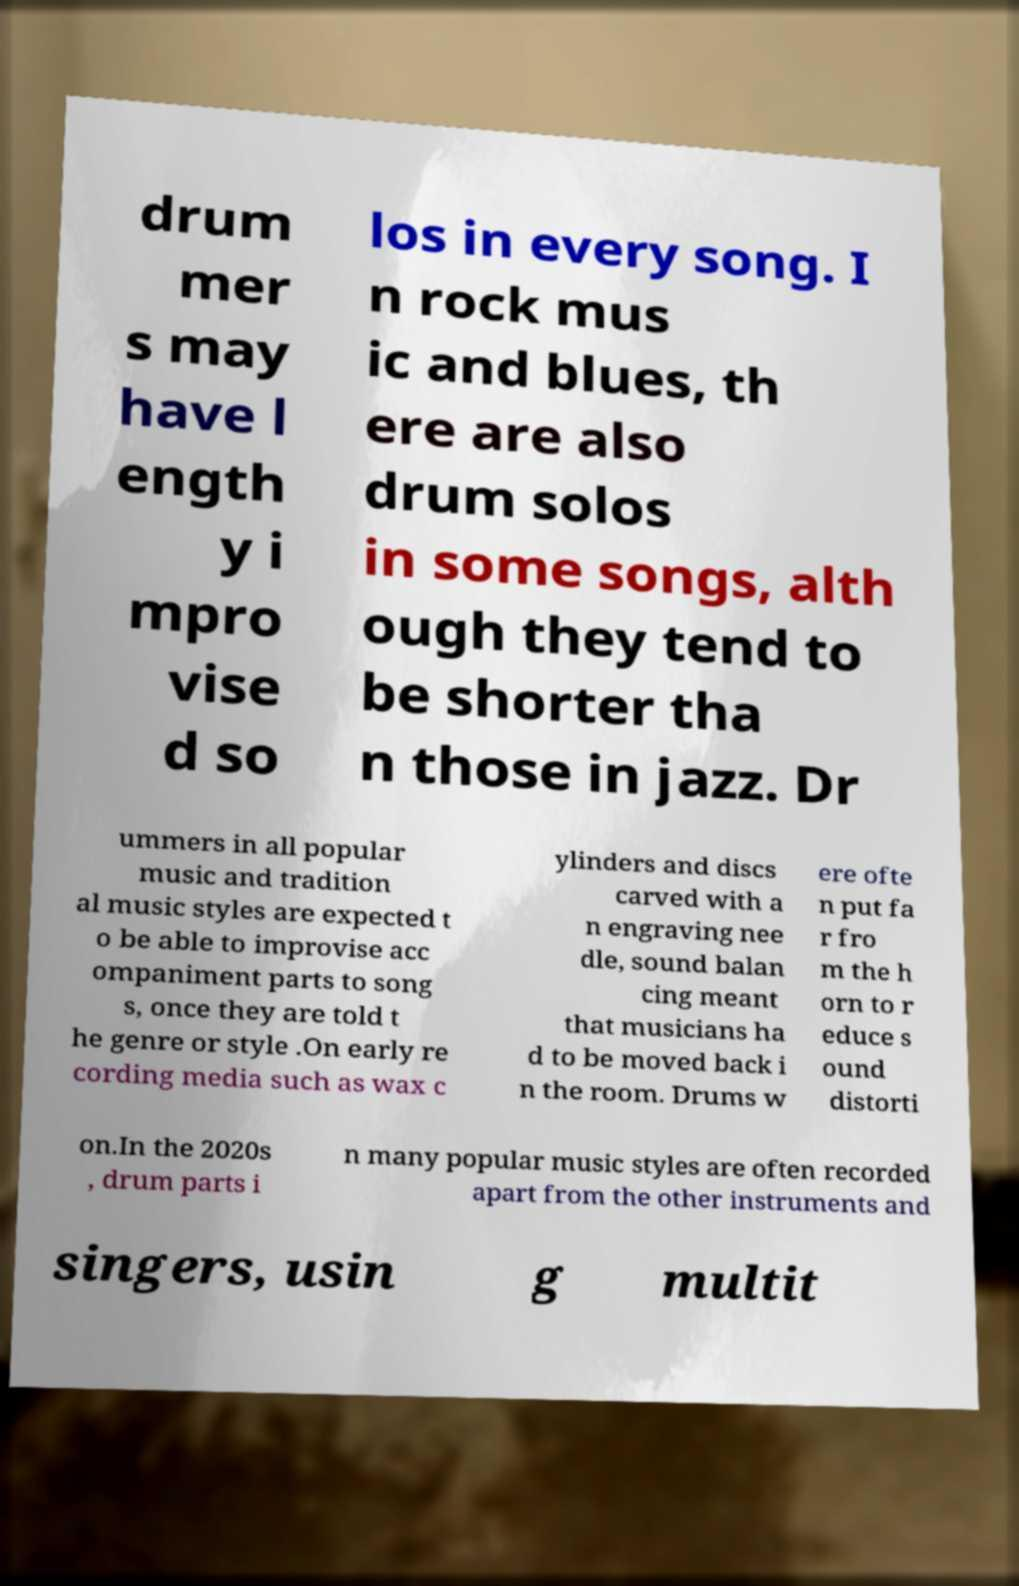Please read and relay the text visible in this image. What does it say? drum mer s may have l ength y i mpro vise d so los in every song. I n rock mus ic and blues, th ere are also drum solos in some songs, alth ough they tend to be shorter tha n those in jazz. Dr ummers in all popular music and tradition al music styles are expected t o be able to improvise acc ompaniment parts to song s, once they are told t he genre or style .On early re cording media such as wax c ylinders and discs carved with a n engraving nee dle, sound balan cing meant that musicians ha d to be moved back i n the room. Drums w ere ofte n put fa r fro m the h orn to r educe s ound distorti on.In the 2020s , drum parts i n many popular music styles are often recorded apart from the other instruments and singers, usin g multit 